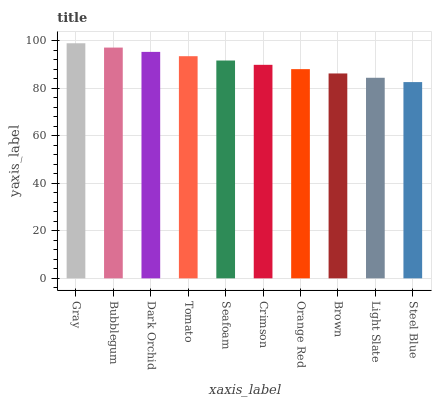Is Steel Blue the minimum?
Answer yes or no. Yes. Is Gray the maximum?
Answer yes or no. Yes. Is Bubblegum the minimum?
Answer yes or no. No. Is Bubblegum the maximum?
Answer yes or no. No. Is Gray greater than Bubblegum?
Answer yes or no. Yes. Is Bubblegum less than Gray?
Answer yes or no. Yes. Is Bubblegum greater than Gray?
Answer yes or no. No. Is Gray less than Bubblegum?
Answer yes or no. No. Is Seafoam the high median?
Answer yes or no. Yes. Is Crimson the low median?
Answer yes or no. Yes. Is Orange Red the high median?
Answer yes or no. No. Is Bubblegum the low median?
Answer yes or no. No. 